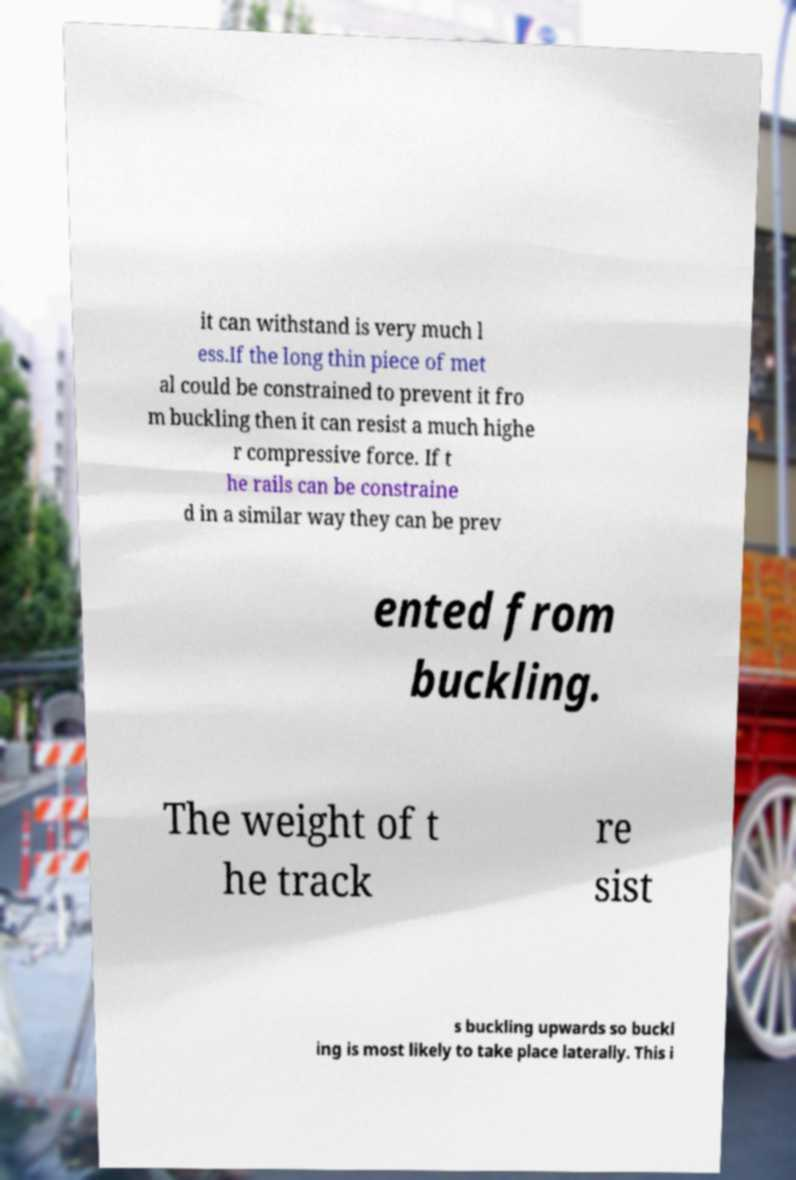Could you assist in decoding the text presented in this image and type it out clearly? it can withstand is very much l ess.If the long thin piece of met al could be constrained to prevent it fro m buckling then it can resist a much highe r compressive force. If t he rails can be constraine d in a similar way they can be prev ented from buckling. The weight of t he track re sist s buckling upwards so buckl ing is most likely to take place laterally. This i 